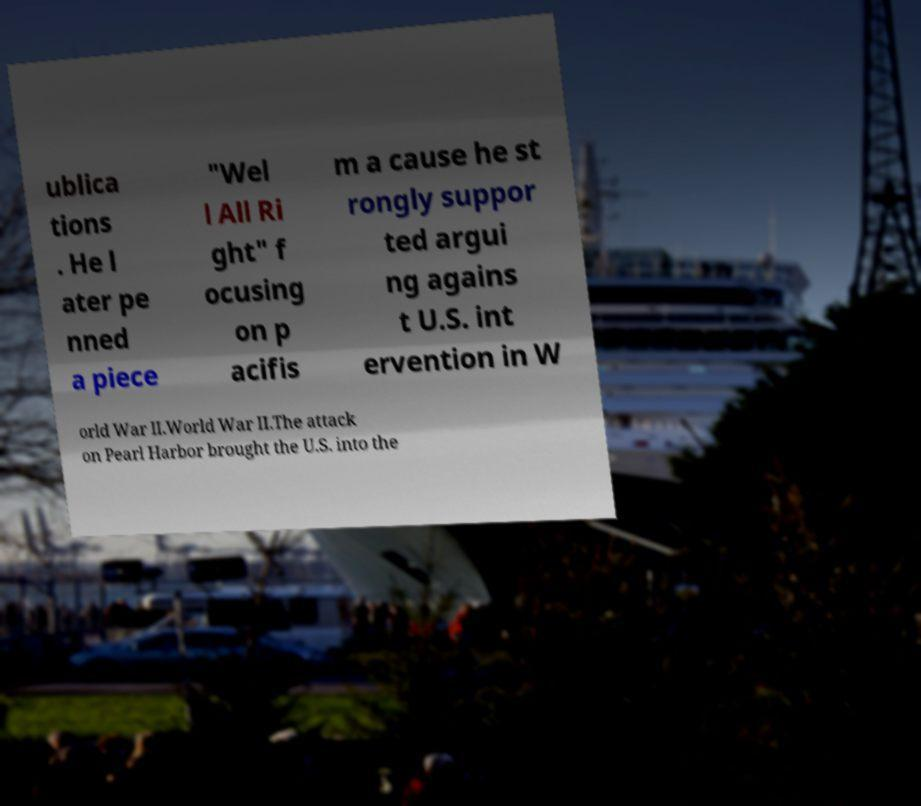Could you extract and type out the text from this image? ublica tions . He l ater pe nned a piece "Wel l All Ri ght" f ocusing on p acifis m a cause he st rongly suppor ted argui ng agains t U.S. int ervention in W orld War II.World War II.The attack on Pearl Harbor brought the U.S. into the 